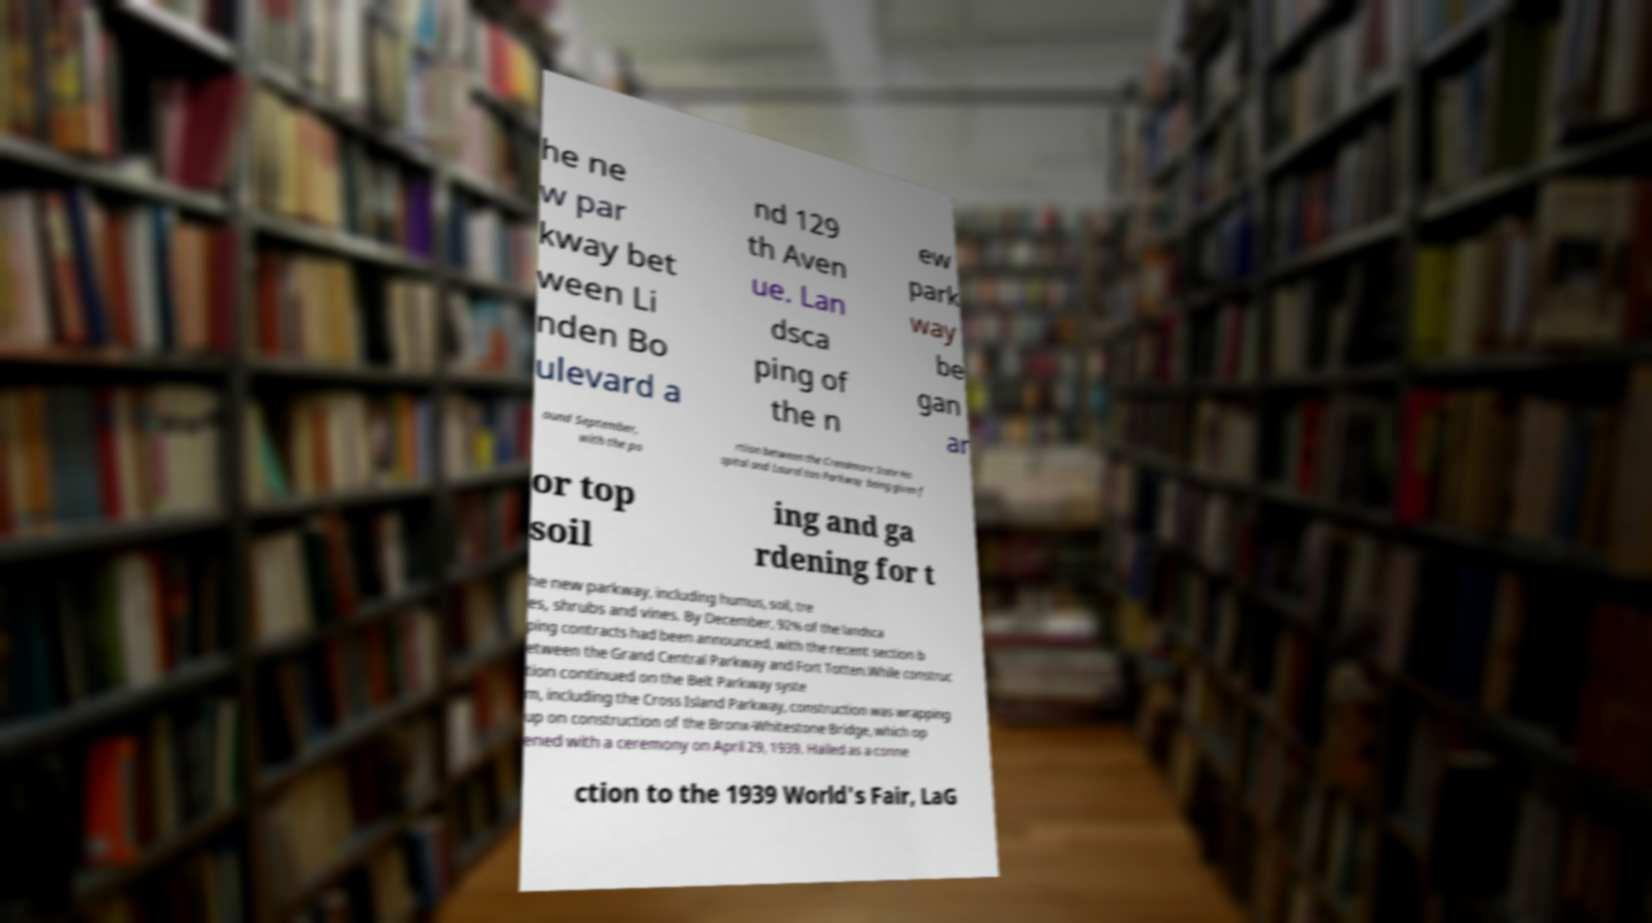Please read and relay the text visible in this image. What does it say? he ne w par kway bet ween Li nden Bo ulevard a nd 129 th Aven ue. Lan dsca ping of the n ew park way be gan ar ound September, with the po rtion between the Creedmore State Ho spital and Laurel ton Parkway being given f or top soil ing and ga rdening for t he new parkway, including humus, soil, tre es, shrubs and vines. By December, 92% of the landsca ping contracts had been announced, with the recent section b etween the Grand Central Parkway and Fort Totten.While construc tion continued on the Belt Parkway syste m, including the Cross Island Parkway, construction was wrapping up on construction of the Bronx-Whitestone Bridge, which op ened with a ceremony on April 29, 1939. Hailed as a conne ction to the 1939 World's Fair, LaG 